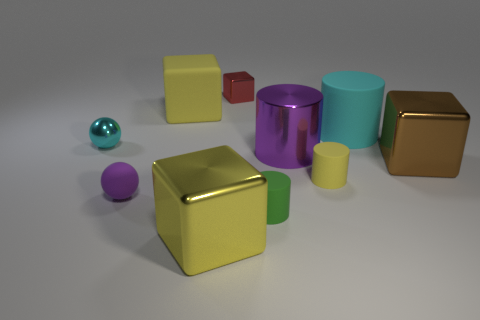Subtract 1 cylinders. How many cylinders are left? 3 Subtract all blue cylinders. Subtract all yellow cubes. How many cylinders are left? 4 Subtract all balls. How many objects are left? 8 Subtract 0 green spheres. How many objects are left? 10 Subtract all large purple metallic cylinders. Subtract all large brown cubes. How many objects are left? 8 Add 4 brown objects. How many brown objects are left? 5 Add 6 tiny cyan balls. How many tiny cyan balls exist? 7 